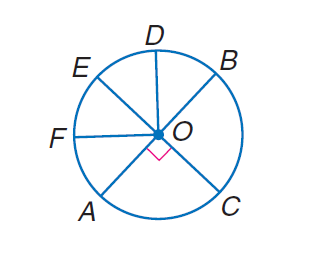Answer the mathemtical geometry problem and directly provide the correct option letter.
Question: In \odot O, E C and A B are diameters, and \angle B O D \cong \angle D O E \cong \angle E O F \cong \angle F O A. Find m \widehat A C B.
Choices: A: 45 B: 90 C: 180 D: 360 C 